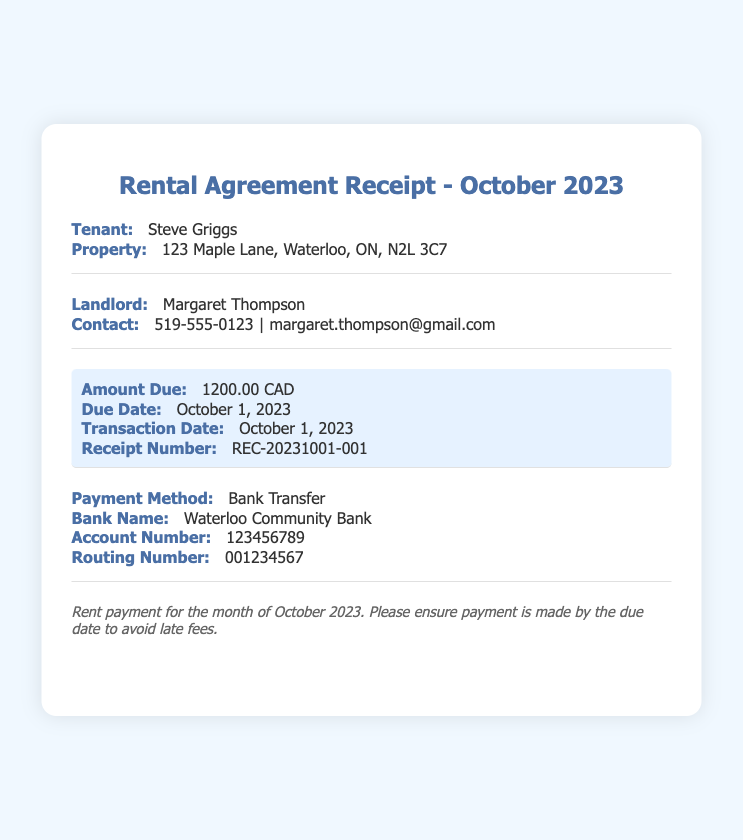What is the due date for the rent? The due date for the rent is specified in the document and is stated clearly as October 1, 2023.
Answer: October 1, 2023 Who is the landlord? The landlord's name is given in the document, allowing us to identify her as Margaret Thompson.
Answer: Margaret Thompson What is the contact number for the landlord? The contact number for the landlord is included in the document under the contact information section, which shows 519-555-0123.
Answer: 519-555-0123 What is the amount due for October 2023? The amount due is highlighted in the document and is explicitly stated as 1200.00 CAD.
Answer: 1200.00 CAD What payment method was used for the transaction? The payment method used is mentioned in the document, specifically noting Bank Transfer as the method employed.
Answer: Bank Transfer How much was paid in total for the month? The total payment for the month is directly provided in the document and is clearly 1200.00 CAD.
Answer: 1200.00 CAD What is the transaction date? The transaction date is indicated in the document as the same date as the due date, which is October 1, 2023.
Answer: October 1, 2023 What is the receipt number? The document provides a unique identifier for this transaction, which is specified as REC-20231001-001.
Answer: REC-20231001-001 Which bank was used for the payment? The name of the bank utilized for the payment is mentioned in the document as Waterloo Community Bank.
Answer: Waterloo Community Bank 